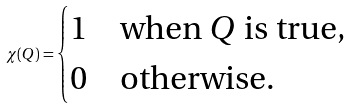Convert formula to latex. <formula><loc_0><loc_0><loc_500><loc_500>\chi ( Q ) = \begin{cases} 1 & \text {when } Q \text { is true} , \\ 0 & \text {otherwise} . \end{cases}</formula> 